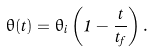Convert formula to latex. <formula><loc_0><loc_0><loc_500><loc_500>\theta ( t ) = \theta _ { i } \left ( 1 - \frac { t } { t _ { f } } \right ) .</formula> 